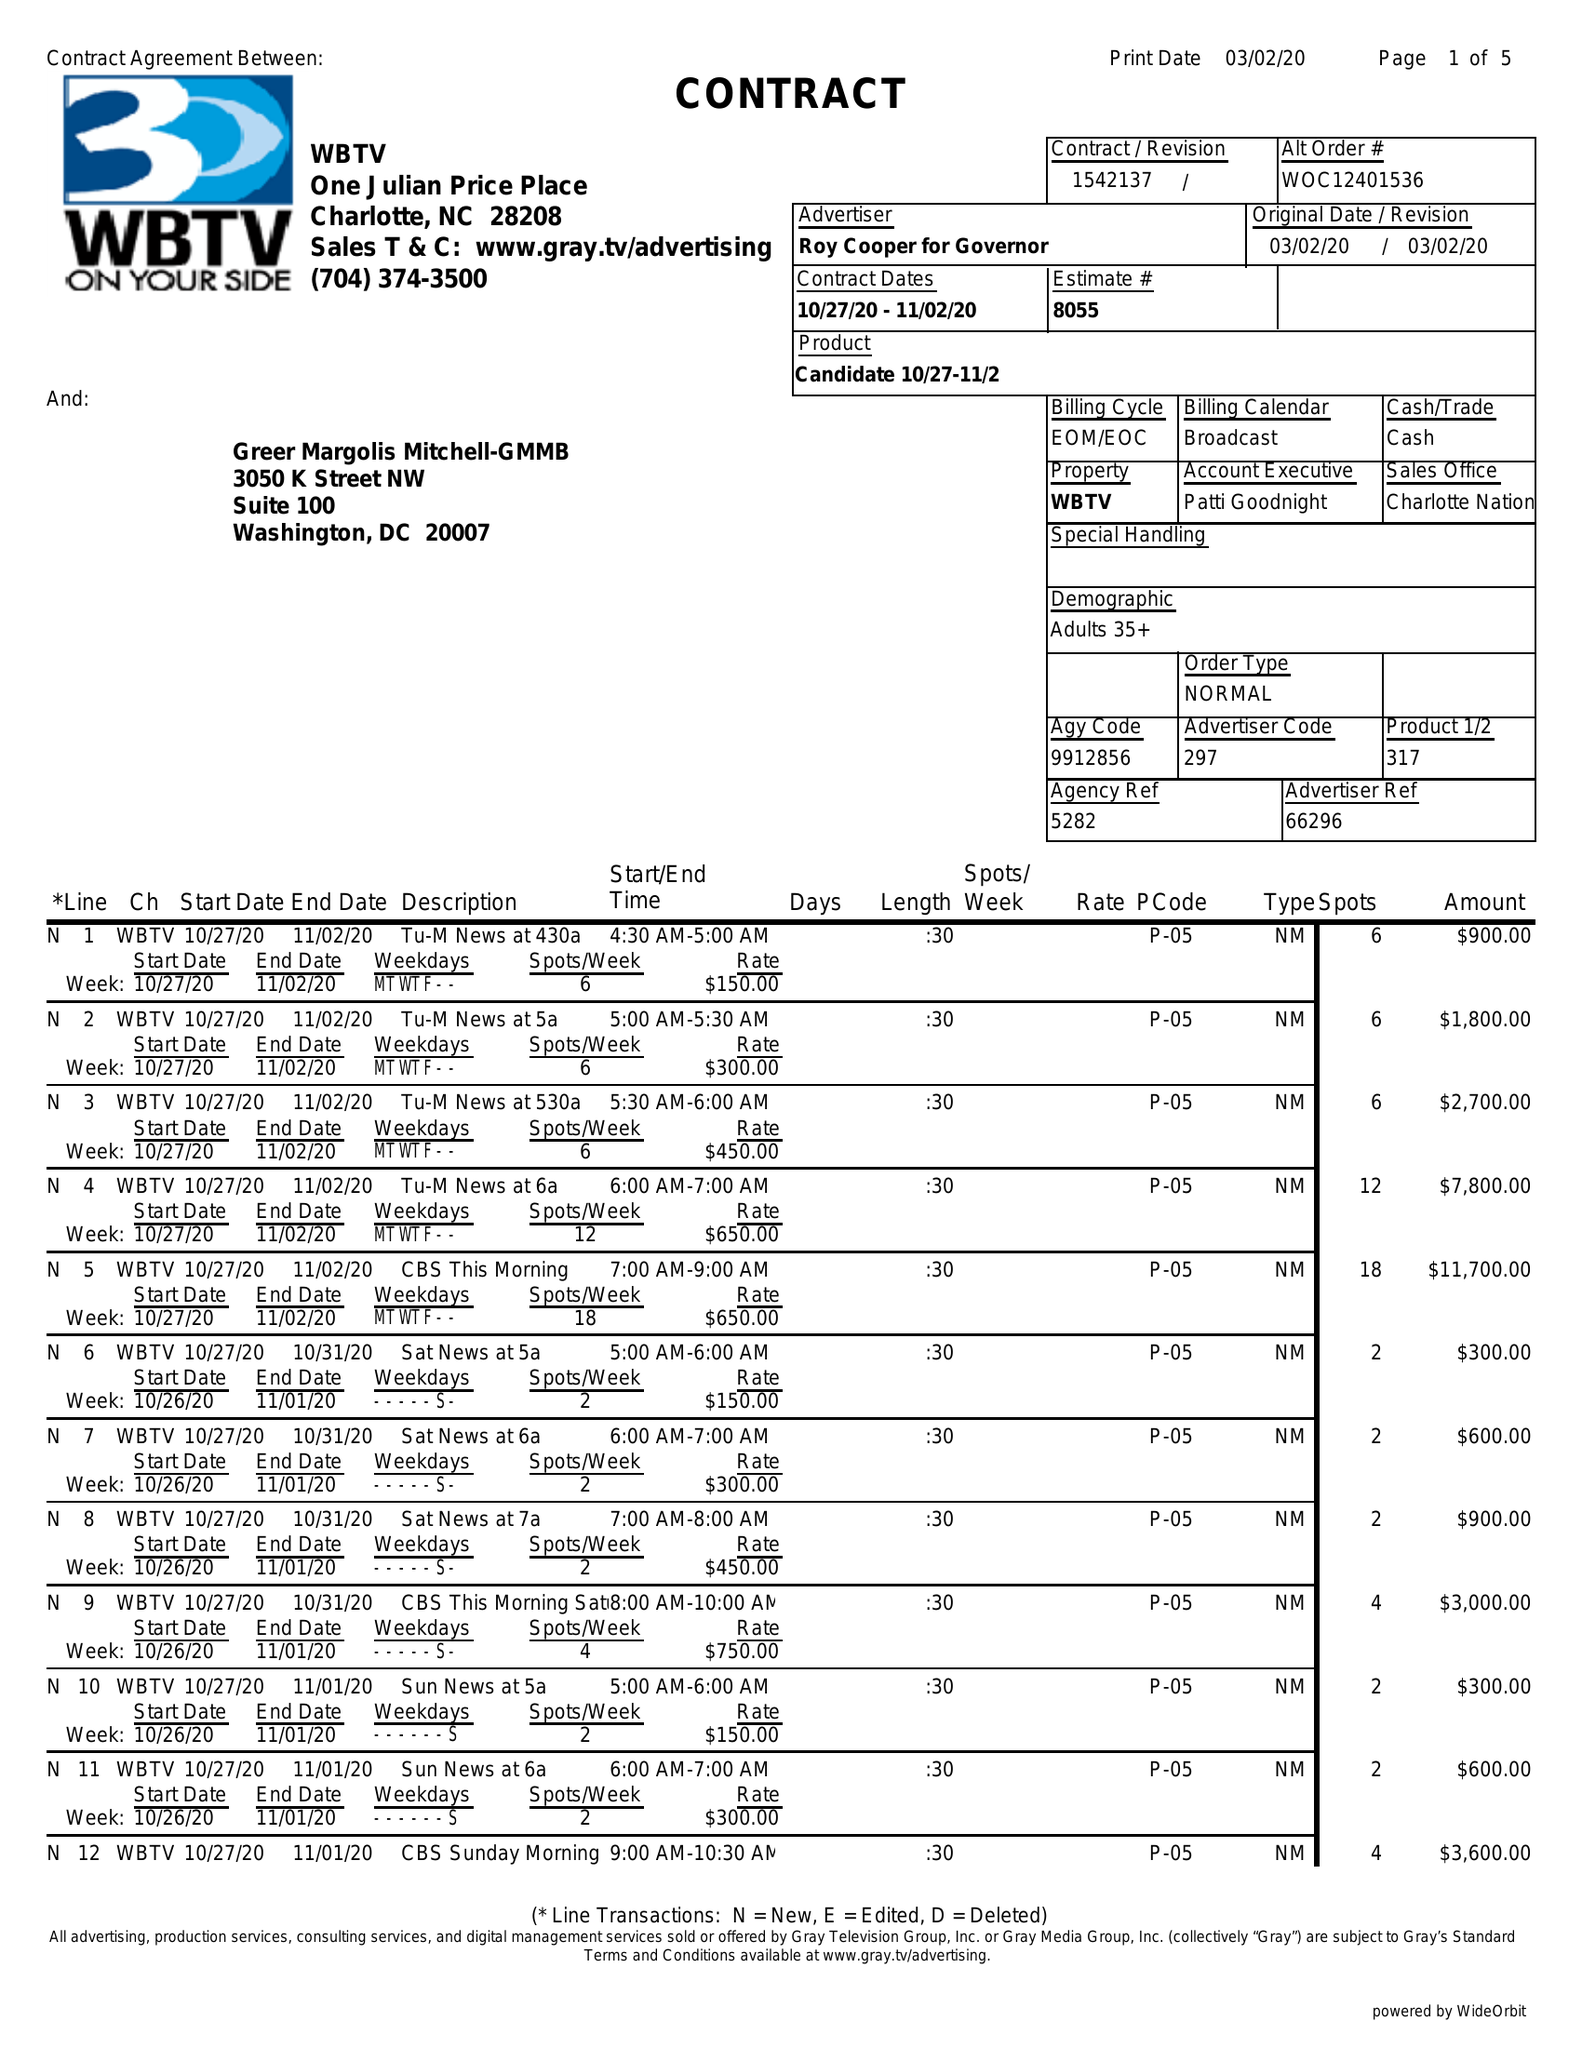What is the value for the flight_to?
Answer the question using a single word or phrase. 11/02/20 